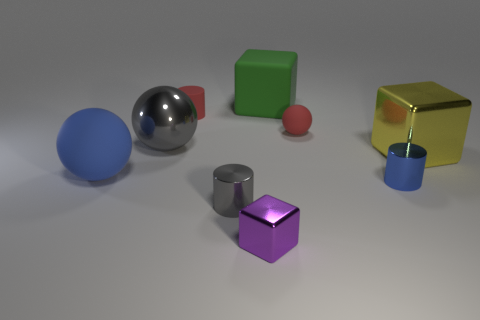What is the shape of the red rubber thing that is to the right of the large green rubber block?
Offer a terse response. Sphere. Is the number of big brown shiny blocks less than the number of red cylinders?
Provide a succinct answer. Yes. Is there a cube that is behind the big shiny object to the left of the small cylinder that is behind the blue metallic cylinder?
Your answer should be very brief. Yes. How many rubber things are large blue spheres or tiny red things?
Provide a short and direct response. 3. Does the big metallic ball have the same color as the matte cube?
Your response must be concise. No. How many rubber cubes are on the left side of the gray shiny cylinder?
Offer a terse response. 0. What number of large rubber things are in front of the large yellow metallic block and behind the large yellow thing?
Make the answer very short. 0. What is the shape of the big green object that is made of the same material as the small red sphere?
Offer a very short reply. Cube. There is a shiny block behind the big blue sphere; is it the same size as the matte object right of the green matte thing?
Keep it short and to the point. No. There is a big rubber thing that is behind the big gray metal sphere; what is its color?
Offer a terse response. Green. 